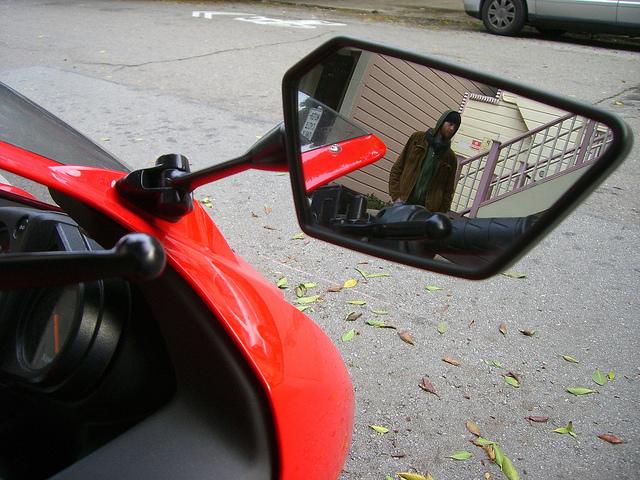What color is the vehicle?
Answer briefly. Red. What color is the banister?
Be succinct. Gray. How many men are there?
Keep it brief. 1. 